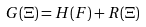<formula> <loc_0><loc_0><loc_500><loc_500>G ( \Xi ) = H ( F ) + R ( \Xi )</formula> 